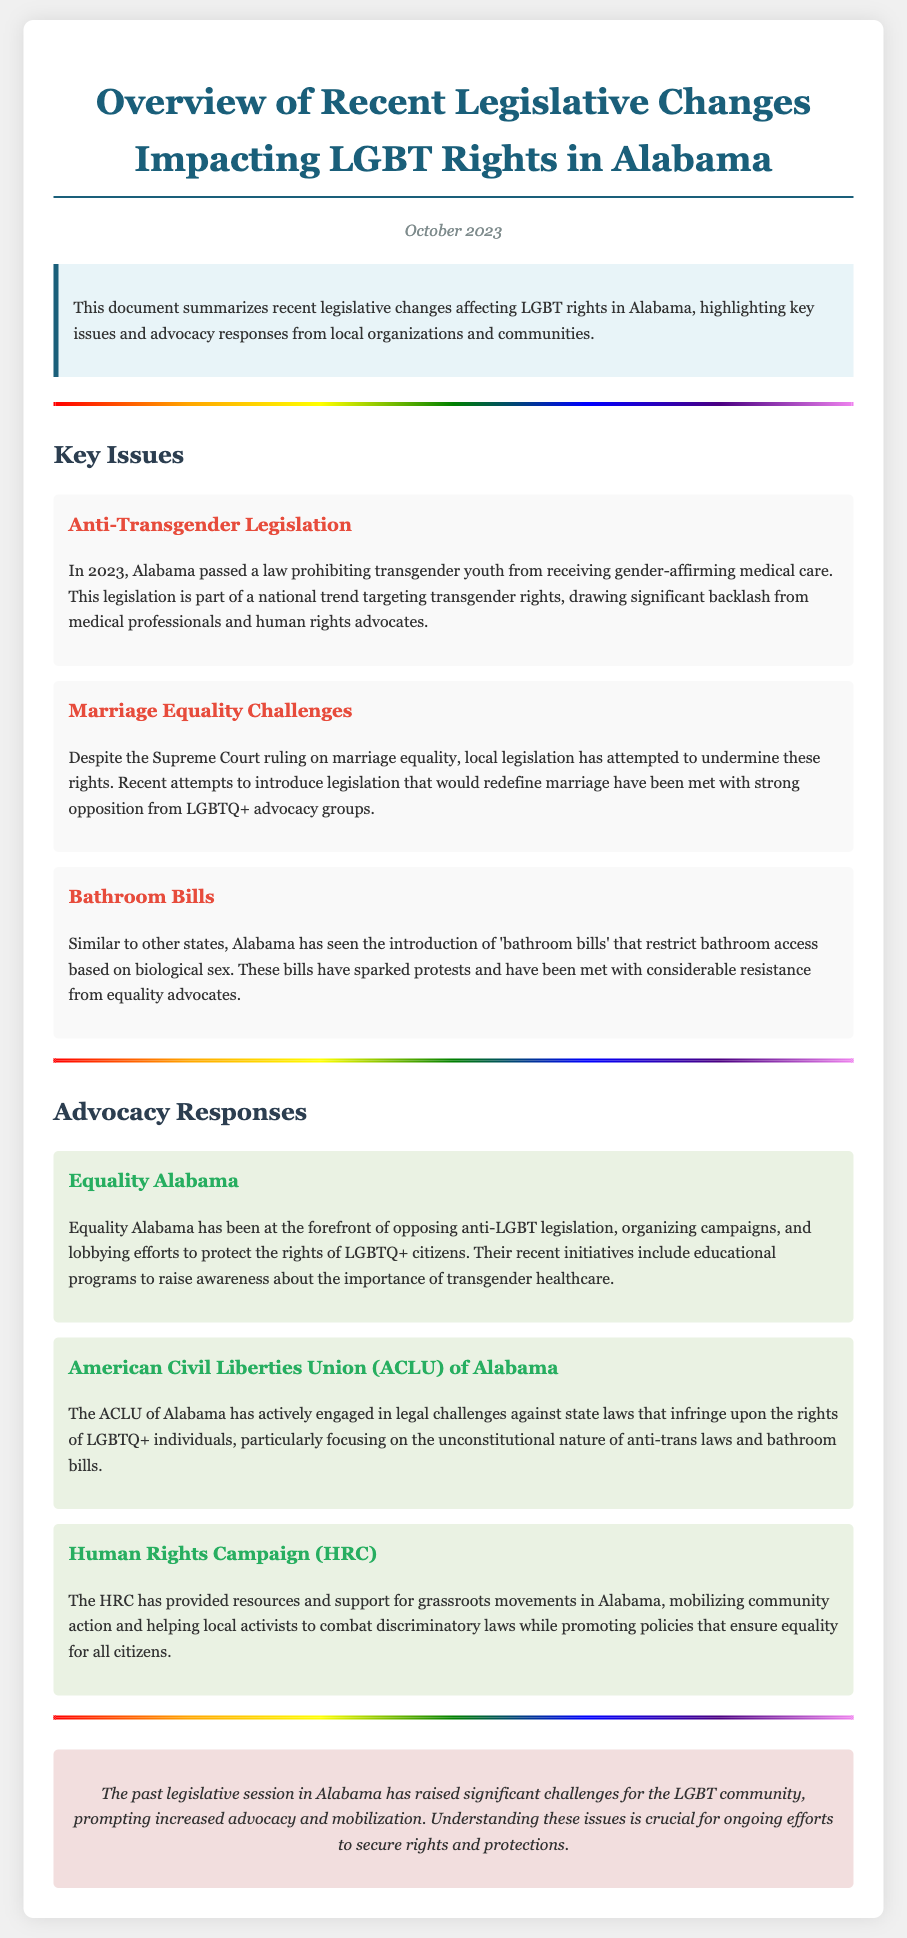What is the year of the recent legislative changes? The document states the legislative changes occurred in October 2023.
Answer: 2023 What organization has been at the forefront of opposing anti-LGBT legislation in Alabama? The document mentions Equality Alabama as the leading organization in opposing such legislation.
Answer: Equality Alabama What type of law was passed prohibiting transgender youth from receiving certain medical care? The document describes this legislation as anti-transgender legislation.
Answer: Anti-transgender What has the ACLU of Alabama focused on regarding state laws? The ACLU has been engaged in legal challenges against laws infringing LGBTQ+ rights, particularly focusing on anti-trans laws.
Answer: Legal challenges What was one of the key responses from the Human Rights Campaign? The document states HRC provided resources and support for grassroots movements in Alabama.
Answer: Resources and support What specific legislation has drawn significant backlash from medical professionals and advocates? The document indicates backlash was due to the law prohibiting gender-affirming medical care for transgender youth.
Answer: Gender-affirming medical care prohibition What legislative trend is noted in Alabama similar to other states? The document refers to 'bathroom bills' as a legislative trend similar to what other states have encountered.
Answer: Bathroom bills What is the main concern of the advocacy groups mentioned in the document? The advocacy groups are primarily concerned with protecting the rights of LGBTQ+ individuals in Alabama.
Answer: Protecting rights 